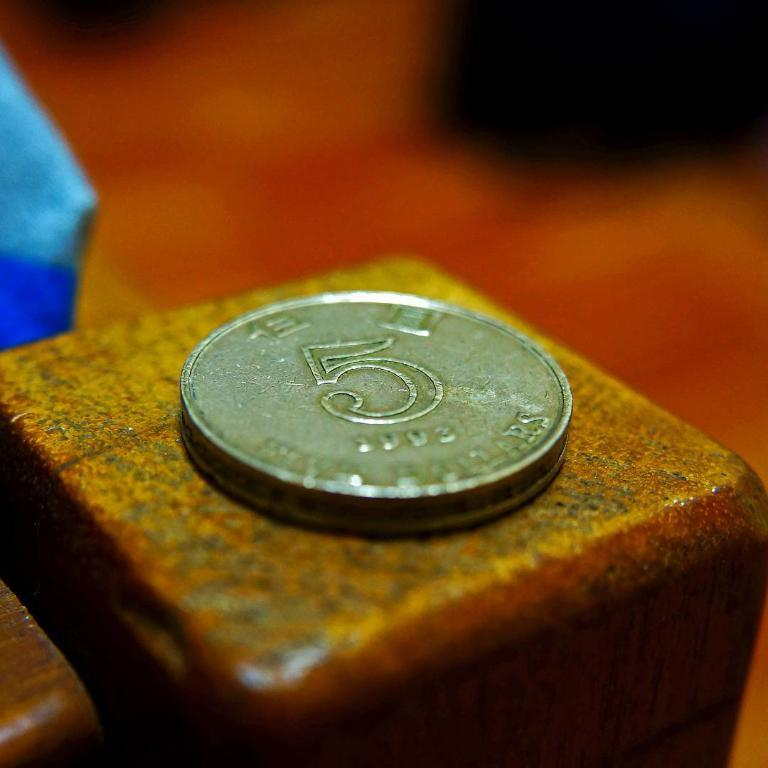<image>
Describe the image concisely. A 5 cent coin is resting on a wooden block. 